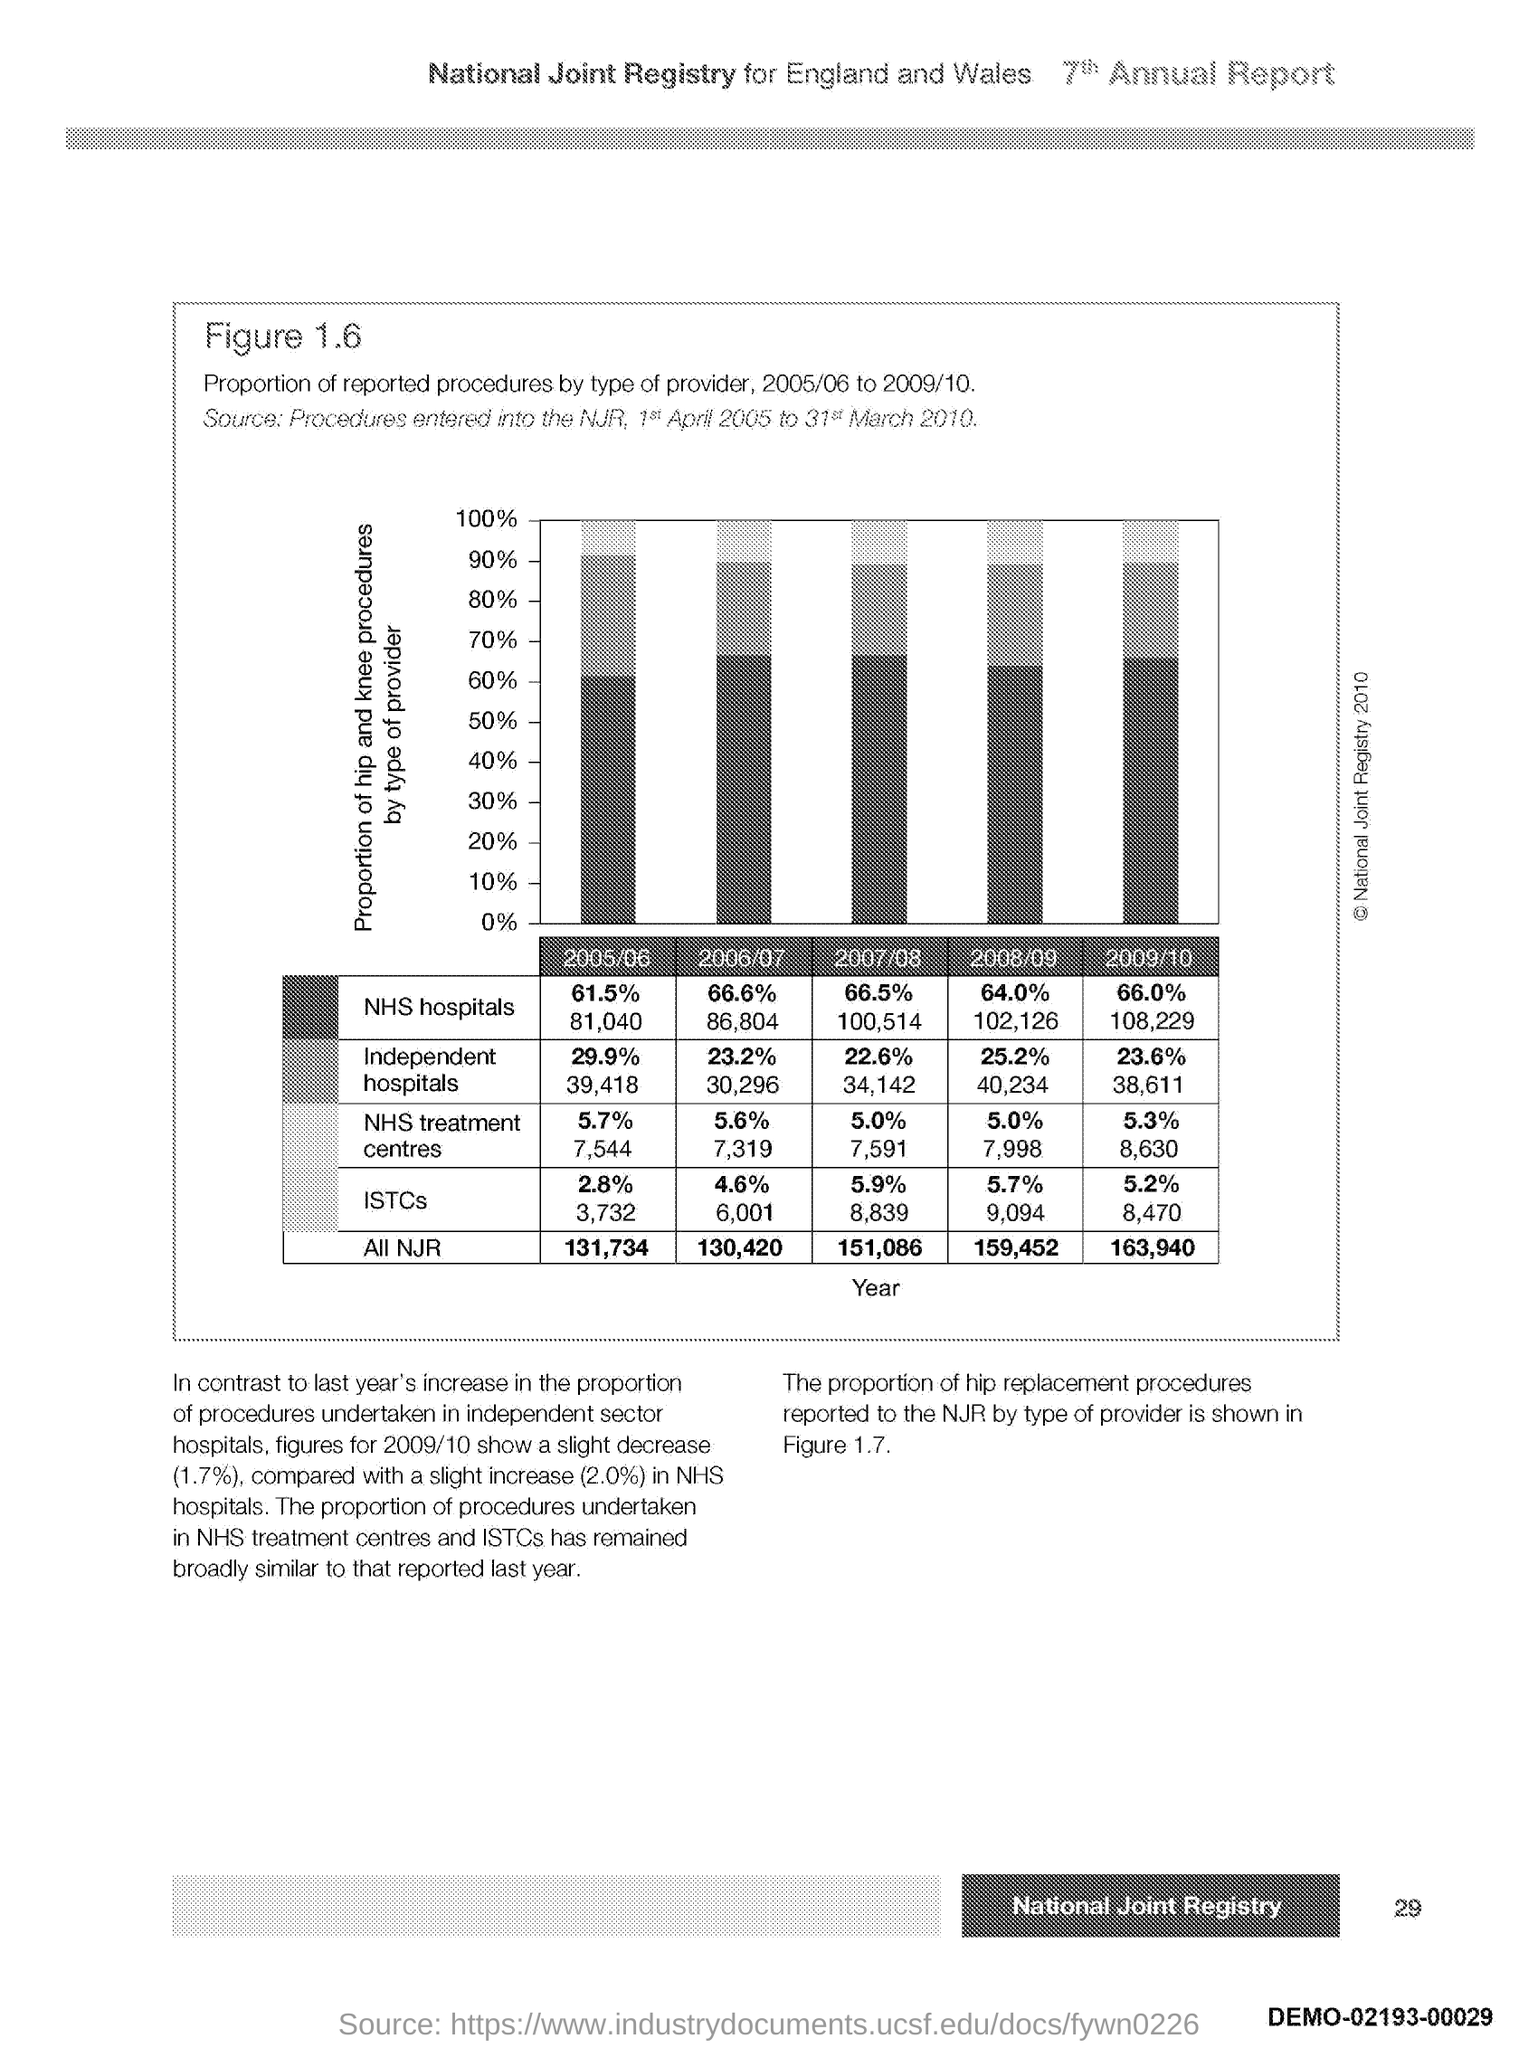Indicate a few pertinent items in this graphic. The x-axis contains information about the year. 